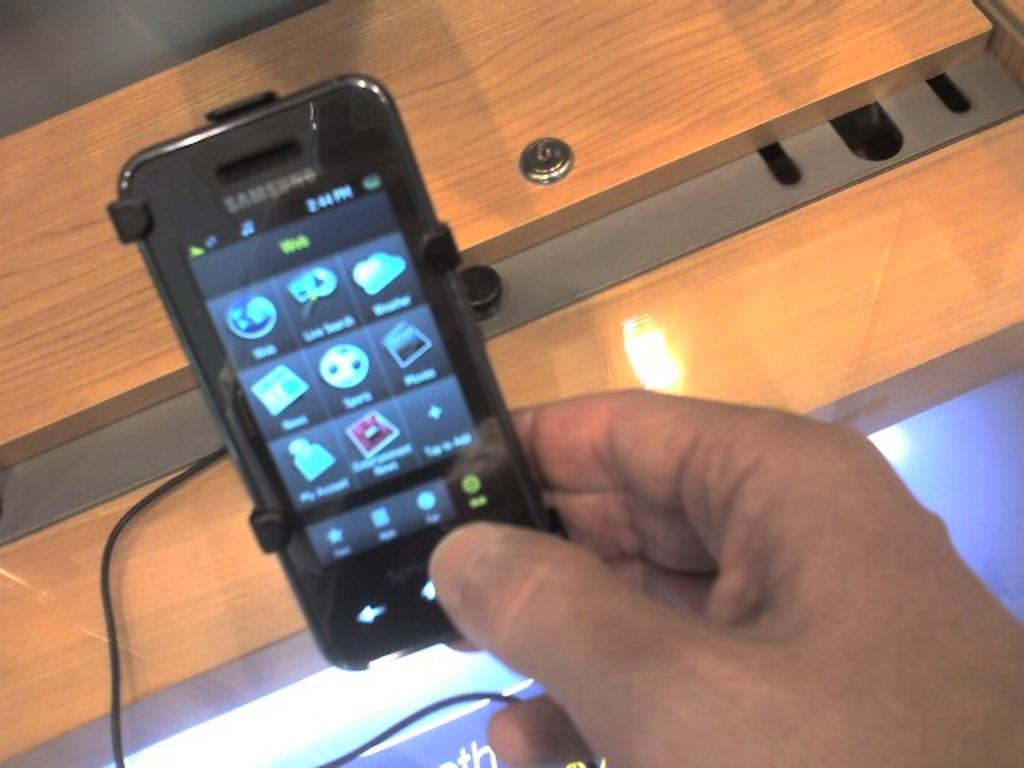<image>
Present a compact description of the photo's key features. A man is holding a Samsung smartphone that is plugged into the display counter of a store. 